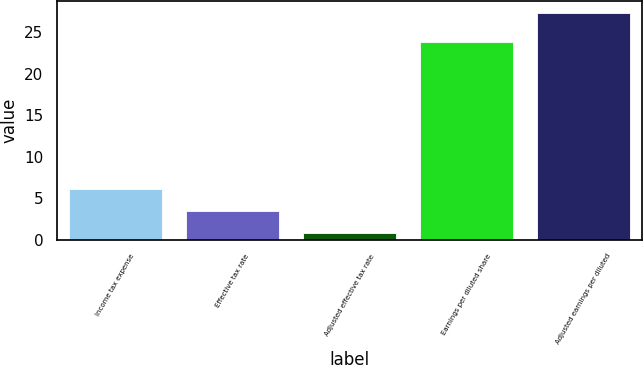Convert chart. <chart><loc_0><loc_0><loc_500><loc_500><bar_chart><fcel>Income tax expense<fcel>Effective tax rate<fcel>Adjusted effective tax rate<fcel>Earnings per diluted share<fcel>Adjusted earnings per diluted<nl><fcel>6.12<fcel>3.46<fcel>0.8<fcel>23.9<fcel>27.4<nl></chart> 